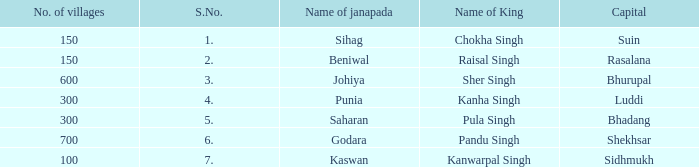What is the highest S number with a capital of Shekhsar? 6.0. 